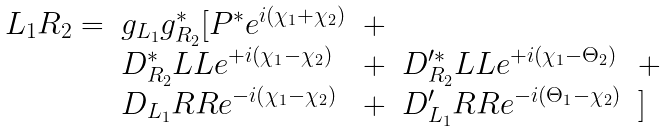<formula> <loc_0><loc_0><loc_500><loc_500>\begin{array} { l l l l l } L _ { 1 } R _ { 2 } = & g _ { L _ { 1 } } g _ { R _ { 2 } } ^ { * } [ P ^ { * } e ^ { i ( \chi _ { 1 } + \chi _ { 2 } ) } & + \\ & D ^ { * } _ { R _ { 2 } } L L e ^ { + i ( \chi _ { 1 } - \chi _ { 2 } ) } & + & D ^ { \prime * } _ { R _ { 2 } } L L e ^ { + i ( \chi _ { 1 } - \Theta _ { 2 } ) } & + \\ & D _ { L _ { 1 } } R R e ^ { - i ( \chi _ { 1 } - \chi _ { 2 } ) } & + & D ^ { \prime } _ { L _ { 1 } } R R e ^ { - i ( \Theta _ { 1 } - \chi _ { 2 } ) } & ] \end{array}</formula> 